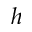Convert formula to latex. <formula><loc_0><loc_0><loc_500><loc_500>h</formula> 